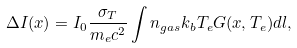<formula> <loc_0><loc_0><loc_500><loc_500>\Delta I ( x ) = I _ { 0 } \frac { \sigma _ { T } } { m _ { e } c ^ { 2 } } \int n _ { g a s } k _ { b } T _ { e } G ( x , T _ { e } ) d l ,</formula> 